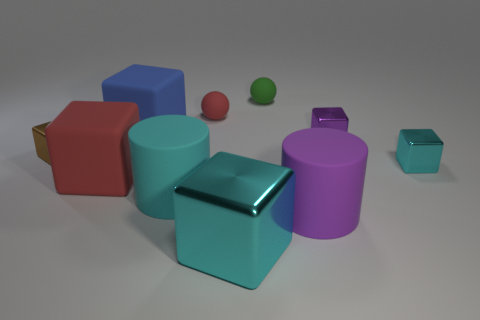Subtract all blue blocks. How many blocks are left? 5 Subtract all purple blocks. How many blocks are left? 5 Subtract 1 cylinders. How many cylinders are left? 1 Subtract all red cylinders. Subtract all green cubes. How many cylinders are left? 2 Subtract all red blocks. How many blue cylinders are left? 0 Subtract all cylinders. Subtract all tiny rubber spheres. How many objects are left? 6 Add 9 small purple metallic cubes. How many small purple metallic cubes are left? 10 Add 6 small green shiny cylinders. How many small green shiny cylinders exist? 6 Subtract 1 purple blocks. How many objects are left? 9 Subtract all cylinders. How many objects are left? 8 